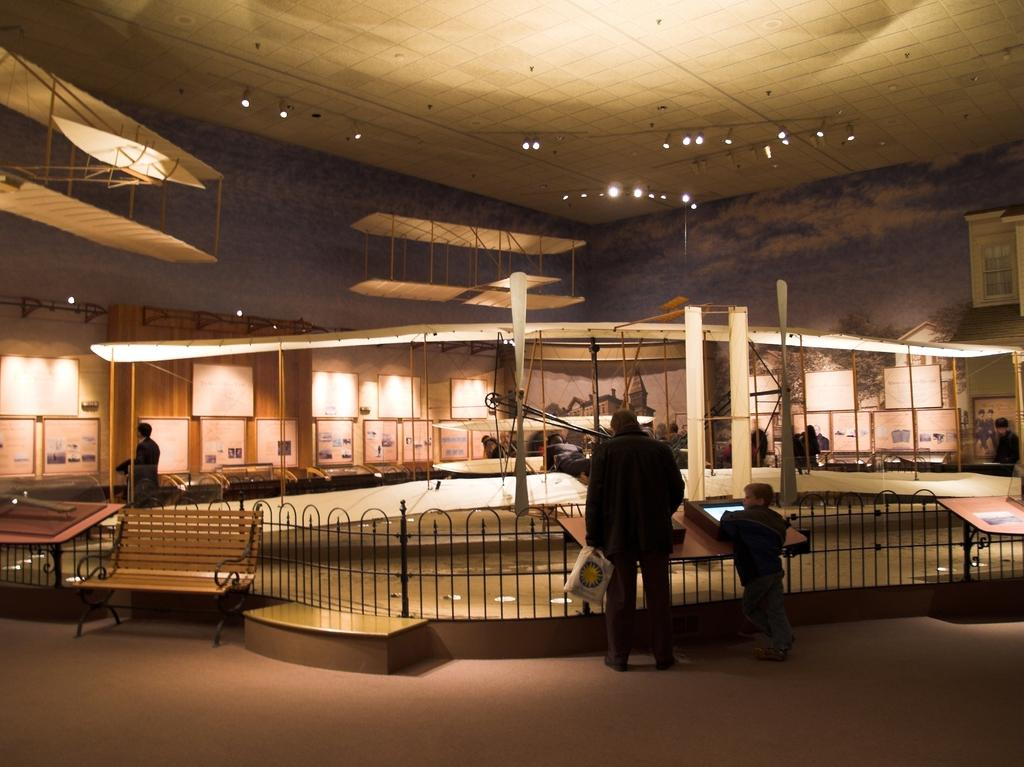What are the people in the image doing? The people in the image are standing in front of the railing. What can be seen to the left of the people? There is a bench to the left. What is attached to the wall in the back? There are boards attached to the wall in the back. What type of jewel is being displayed on the bench in the image? There is no jewel present in the image; the bench is empty. 